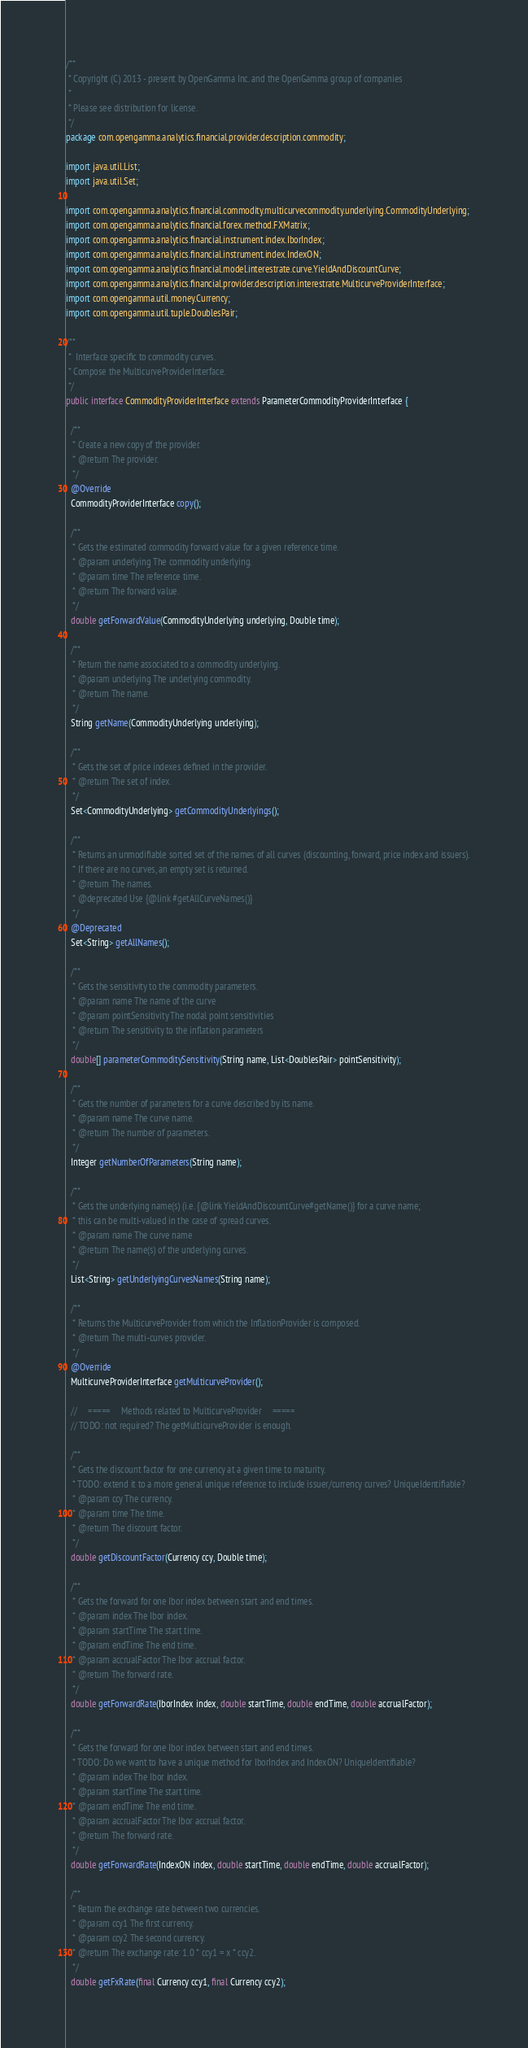Convert code to text. <code><loc_0><loc_0><loc_500><loc_500><_Java_>/**
 * Copyright (C) 2013 - present by OpenGamma Inc. and the OpenGamma group of companies
 *
 * Please see distribution for license.
 */
package com.opengamma.analytics.financial.provider.description.commodity;

import java.util.List;
import java.util.Set;

import com.opengamma.analytics.financial.commodity.multicurvecommodity.underlying.CommodityUnderlying;
import com.opengamma.analytics.financial.forex.method.FXMatrix;
import com.opengamma.analytics.financial.instrument.index.IborIndex;
import com.opengamma.analytics.financial.instrument.index.IndexON;
import com.opengamma.analytics.financial.model.interestrate.curve.YieldAndDiscountCurve;
import com.opengamma.analytics.financial.provider.description.interestrate.MulticurveProviderInterface;
import com.opengamma.util.money.Currency;
import com.opengamma.util.tuple.DoublesPair;

/**
 *  Interface specific to commodity curves.
 * Compose the MulticurveProviderInterface.
 */
public interface CommodityProviderInterface extends ParameterCommodityProviderInterface {

  /**
   * Create a new copy of the provider.
   * @return The provider.
   */
  @Override
  CommodityProviderInterface copy();

  /**
   * Gets the estimated commodity forward value for a given reference time.
   * @param underlying The commodity underlying.
   * @param time The reference time.
   * @return The forward value.
   */
  double getForwardValue(CommodityUnderlying underlying, Double time);

  /**
   * Return the name associated to a commodity underlying.
   * @param underlying The underlying commodity.
   * @return The name.
   */
  String getName(CommodityUnderlying underlying);

  /**
   * Gets the set of price indexes defined in the provider.
   * @return The set of index.
   */
  Set<CommodityUnderlying> getCommodityUnderlyings();

  /**
   * Returns an unmodifiable sorted set of the names of all curves (discounting, forward, price index and issuers).
   * If there are no curves, an empty set is returned.
   * @return The names.
   * @deprecated Use {@link #getAllCurveNames()}
   */
  @Deprecated
  Set<String> getAllNames();

  /**
   * Gets the sensitivity to the commodity parameters.
   * @param name The name of the curve
   * @param pointSensitivity The nodal point sensitivities
   * @return The sensitivity to the inflation parameters
   */
  double[] parameterCommoditySensitivity(String name, List<DoublesPair> pointSensitivity);

  /**
   * Gets the number of parameters for a curve described by its name.
   * @param name The curve name.
   * @return The number of parameters.
   */
  Integer getNumberOfParameters(String name);

  /**
   * Gets the underlying name(s) (i.e. {@link YieldAndDiscountCurve#getName()} for a curve name;
   * this can be multi-valued in the case of spread curves.
   * @param name The curve name
   * @return The name(s) of the underlying curves.
   */
  List<String> getUnderlyingCurvesNames(String name);

  /**
   * Returns the MulticurveProvider from which the InflationProvider is composed.
   * @return The multi-curves provider.
   */
  @Override
  MulticurveProviderInterface getMulticurveProvider();

  //     =====     Methods related to MulticurveProvider     =====
  // TODO: not required? The getMulticurveProvider is enough.

  /**
   * Gets the discount factor for one currency at a given time to maturity.
   * TODO: extend it to a more general unique reference to include issuer/currency curves? UniqueIdentifiable?
   * @param ccy The currency.
   * @param time The time.
   * @return The discount factor.
   */
  double getDiscountFactor(Currency ccy, Double time);

  /**
   * Gets the forward for one Ibor index between start and end times.
   * @param index The Ibor index.
   * @param startTime The start time.
   * @param endTime The end time.
   * @param accrualFactor The Ibor accrual factor.
   * @return The forward rate.
   */
  double getForwardRate(IborIndex index, double startTime, double endTime, double accrualFactor);

  /**
   * Gets the forward for one Ibor index between start and end times.
   * TODO: Do we want to have a unique method for IborIndex and IndexON? UniqueIdentifiable?
   * @param index The Ibor index.
   * @param startTime The start time.
   * @param endTime The end time.
   * @param accrualFactor The Ibor accrual factor.
   * @return The forward rate.
   */
  double getForwardRate(IndexON index, double startTime, double endTime, double accrualFactor);

  /**
   * Return the exchange rate between two currencies.
   * @param ccy1 The first currency.
   * @param ccy2 The second currency.
   * @return The exchange rate: 1.0 * ccy1 = x * ccy2.
   */
  double getFxRate(final Currency ccy1, final Currency ccy2);
</code> 